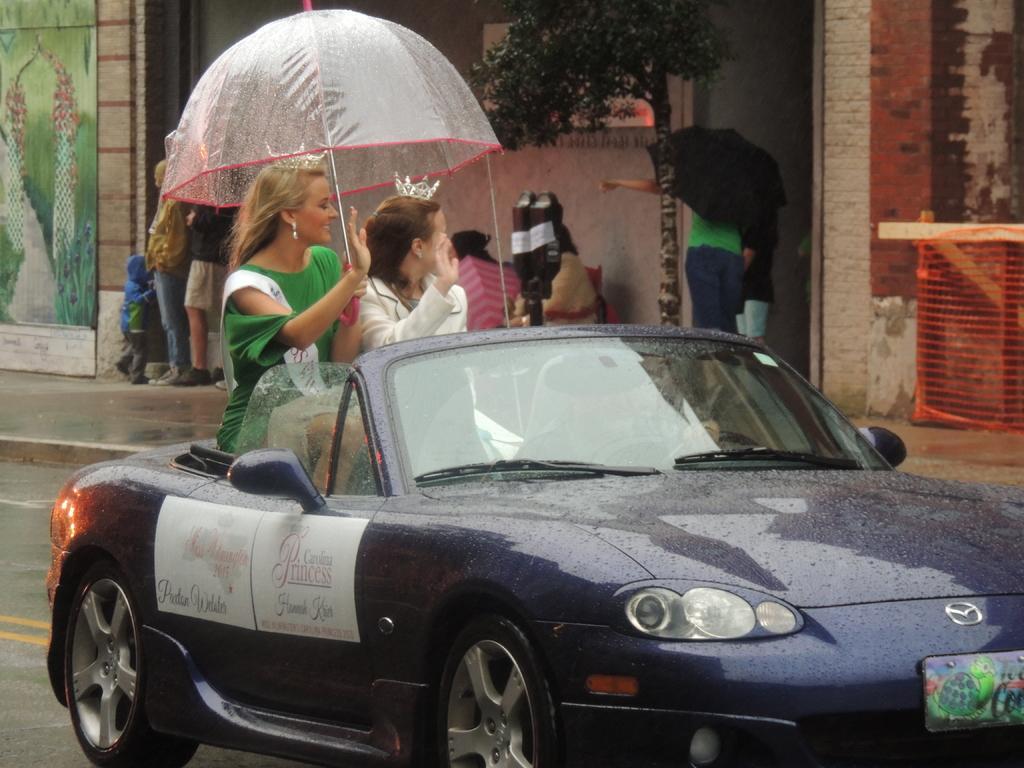In one or two sentences, can you explain what this image depicts? There is a car moving on the road and it is an open top car, two women were sitting in the backseat of the car and they are holding an umbrella. On the right side there is a footpath and some people were standing beside the wall on the footpath. 